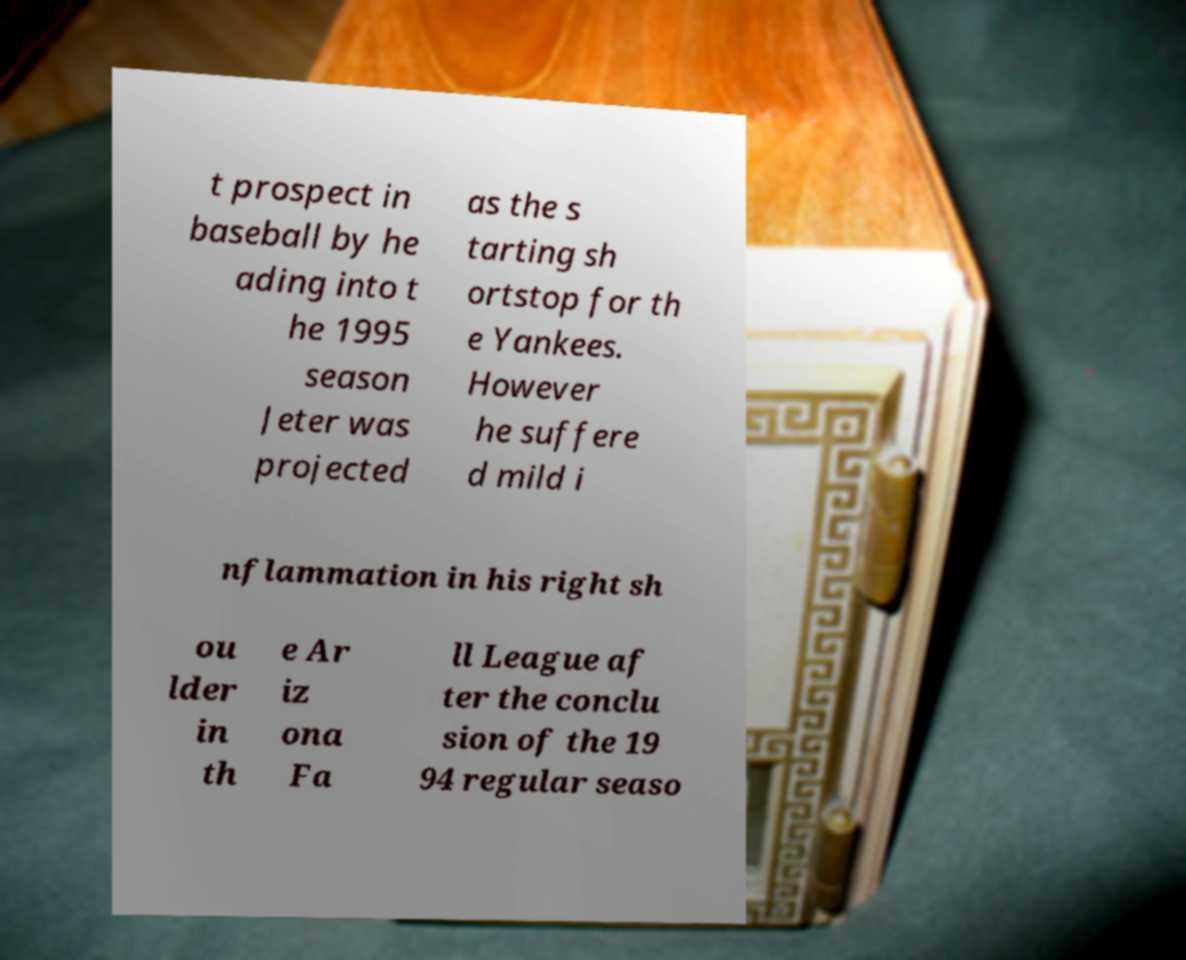I need the written content from this picture converted into text. Can you do that? t prospect in baseball by he ading into t he 1995 season Jeter was projected as the s tarting sh ortstop for th e Yankees. However he suffere d mild i nflammation in his right sh ou lder in th e Ar iz ona Fa ll League af ter the conclu sion of the 19 94 regular seaso 